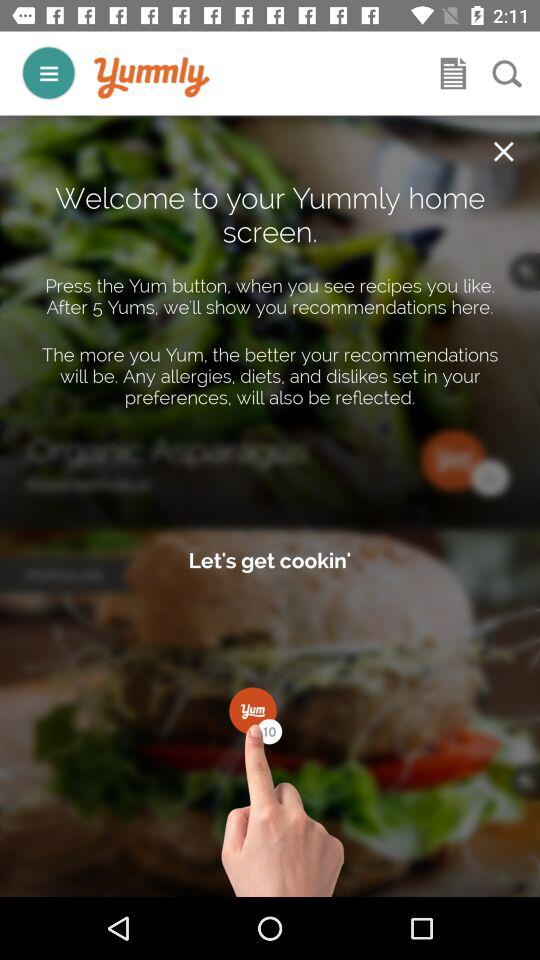How many more Yums do I need to get recommendations?
Answer the question using a single word or phrase. 5 